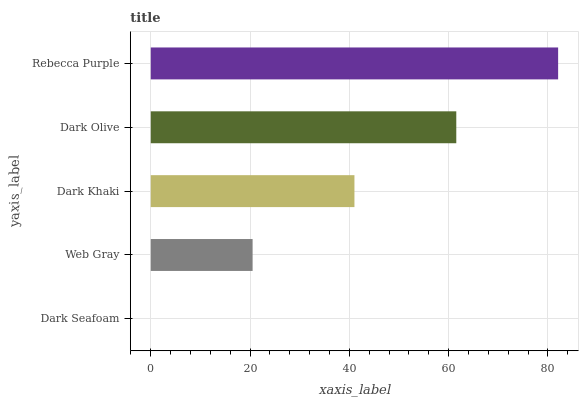Is Dark Seafoam the minimum?
Answer yes or no. Yes. Is Rebecca Purple the maximum?
Answer yes or no. Yes. Is Web Gray the minimum?
Answer yes or no. No. Is Web Gray the maximum?
Answer yes or no. No. Is Web Gray greater than Dark Seafoam?
Answer yes or no. Yes. Is Dark Seafoam less than Web Gray?
Answer yes or no. Yes. Is Dark Seafoam greater than Web Gray?
Answer yes or no. No. Is Web Gray less than Dark Seafoam?
Answer yes or no. No. Is Dark Khaki the high median?
Answer yes or no. Yes. Is Dark Khaki the low median?
Answer yes or no. Yes. Is Rebecca Purple the high median?
Answer yes or no. No. Is Web Gray the low median?
Answer yes or no. No. 